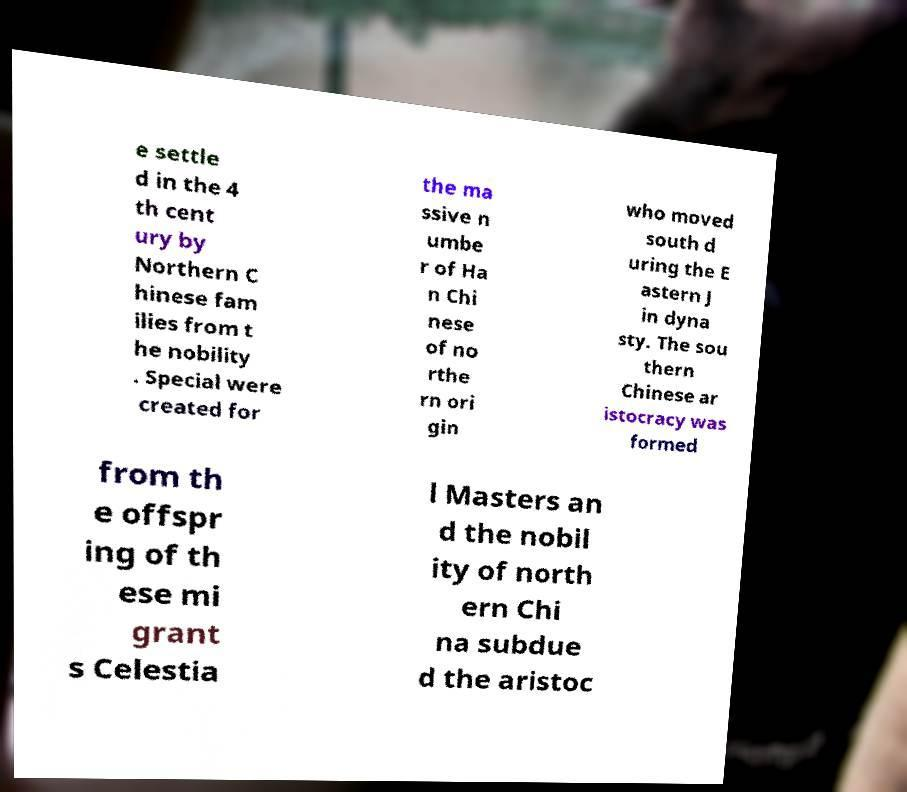I need the written content from this picture converted into text. Can you do that? e settle d in the 4 th cent ury by Northern C hinese fam ilies from t he nobility . Special were created for the ma ssive n umbe r of Ha n Chi nese of no rthe rn ori gin who moved south d uring the E astern J in dyna sty. The sou thern Chinese ar istocracy was formed from th e offspr ing of th ese mi grant s Celestia l Masters an d the nobil ity of north ern Chi na subdue d the aristoc 